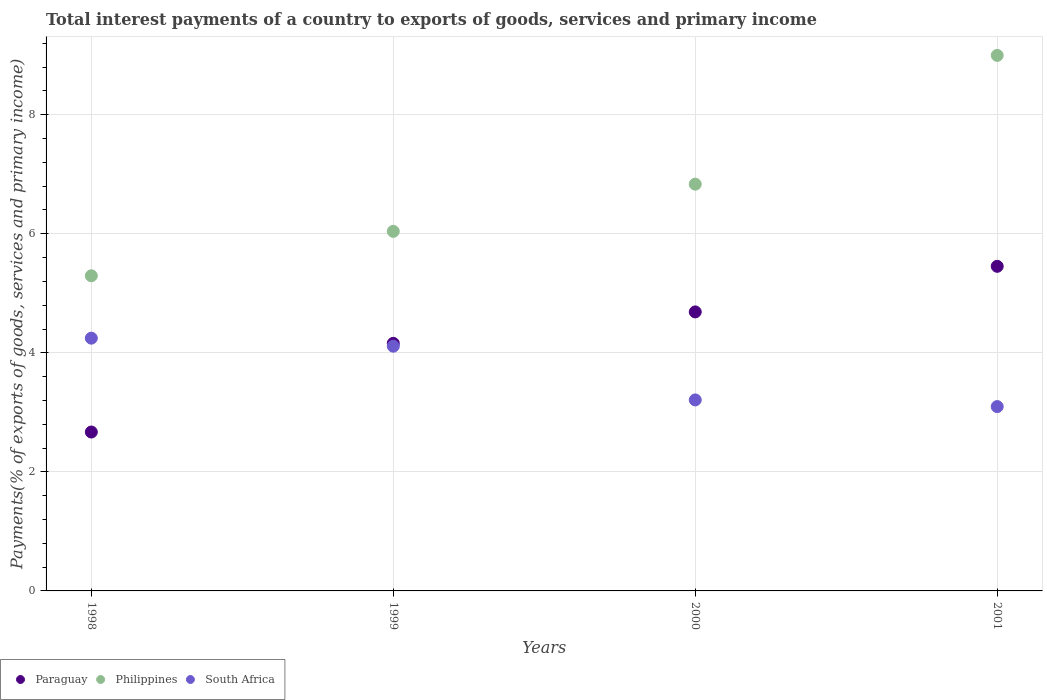How many different coloured dotlines are there?
Your response must be concise. 3. Is the number of dotlines equal to the number of legend labels?
Your answer should be very brief. Yes. What is the total interest payments in Paraguay in 1999?
Your answer should be very brief. 4.16. Across all years, what is the maximum total interest payments in Paraguay?
Offer a terse response. 5.45. Across all years, what is the minimum total interest payments in Philippines?
Provide a short and direct response. 5.29. What is the total total interest payments in South Africa in the graph?
Provide a succinct answer. 14.66. What is the difference between the total interest payments in Paraguay in 1999 and that in 2000?
Offer a terse response. -0.53. What is the difference between the total interest payments in South Africa in 1998 and the total interest payments in Philippines in 2000?
Your response must be concise. -2.59. What is the average total interest payments in Philippines per year?
Provide a succinct answer. 6.79. In the year 1999, what is the difference between the total interest payments in Paraguay and total interest payments in South Africa?
Ensure brevity in your answer.  0.05. What is the ratio of the total interest payments in Paraguay in 1998 to that in 1999?
Offer a terse response. 0.64. What is the difference between the highest and the second highest total interest payments in Philippines?
Offer a very short reply. 2.16. What is the difference between the highest and the lowest total interest payments in Philippines?
Give a very brief answer. 3.7. Is the total interest payments in Paraguay strictly greater than the total interest payments in South Africa over the years?
Offer a very short reply. No. How are the legend labels stacked?
Your response must be concise. Horizontal. What is the title of the graph?
Keep it short and to the point. Total interest payments of a country to exports of goods, services and primary income. What is the label or title of the Y-axis?
Offer a terse response. Payments(% of exports of goods, services and primary income). What is the Payments(% of exports of goods, services and primary income) of Paraguay in 1998?
Offer a very short reply. 2.67. What is the Payments(% of exports of goods, services and primary income) in Philippines in 1998?
Your response must be concise. 5.29. What is the Payments(% of exports of goods, services and primary income) in South Africa in 1998?
Provide a succinct answer. 4.25. What is the Payments(% of exports of goods, services and primary income) in Paraguay in 1999?
Your answer should be very brief. 4.16. What is the Payments(% of exports of goods, services and primary income) in Philippines in 1999?
Your answer should be compact. 6.04. What is the Payments(% of exports of goods, services and primary income) of South Africa in 1999?
Make the answer very short. 4.11. What is the Payments(% of exports of goods, services and primary income) of Paraguay in 2000?
Make the answer very short. 4.69. What is the Payments(% of exports of goods, services and primary income) of Philippines in 2000?
Provide a short and direct response. 6.83. What is the Payments(% of exports of goods, services and primary income) in South Africa in 2000?
Provide a succinct answer. 3.21. What is the Payments(% of exports of goods, services and primary income) of Paraguay in 2001?
Offer a very short reply. 5.45. What is the Payments(% of exports of goods, services and primary income) of Philippines in 2001?
Your response must be concise. 9. What is the Payments(% of exports of goods, services and primary income) of South Africa in 2001?
Keep it short and to the point. 3.1. Across all years, what is the maximum Payments(% of exports of goods, services and primary income) in Paraguay?
Provide a short and direct response. 5.45. Across all years, what is the maximum Payments(% of exports of goods, services and primary income) of Philippines?
Make the answer very short. 9. Across all years, what is the maximum Payments(% of exports of goods, services and primary income) of South Africa?
Provide a short and direct response. 4.25. Across all years, what is the minimum Payments(% of exports of goods, services and primary income) in Paraguay?
Offer a terse response. 2.67. Across all years, what is the minimum Payments(% of exports of goods, services and primary income) in Philippines?
Your answer should be compact. 5.29. Across all years, what is the minimum Payments(% of exports of goods, services and primary income) in South Africa?
Give a very brief answer. 3.1. What is the total Payments(% of exports of goods, services and primary income) of Paraguay in the graph?
Your answer should be compact. 16.97. What is the total Payments(% of exports of goods, services and primary income) of Philippines in the graph?
Your answer should be very brief. 27.16. What is the total Payments(% of exports of goods, services and primary income) in South Africa in the graph?
Provide a succinct answer. 14.66. What is the difference between the Payments(% of exports of goods, services and primary income) of Paraguay in 1998 and that in 1999?
Keep it short and to the point. -1.49. What is the difference between the Payments(% of exports of goods, services and primary income) of Philippines in 1998 and that in 1999?
Provide a succinct answer. -0.75. What is the difference between the Payments(% of exports of goods, services and primary income) of South Africa in 1998 and that in 1999?
Keep it short and to the point. 0.14. What is the difference between the Payments(% of exports of goods, services and primary income) in Paraguay in 1998 and that in 2000?
Offer a terse response. -2.02. What is the difference between the Payments(% of exports of goods, services and primary income) in Philippines in 1998 and that in 2000?
Make the answer very short. -1.54. What is the difference between the Payments(% of exports of goods, services and primary income) of South Africa in 1998 and that in 2000?
Your answer should be compact. 1.04. What is the difference between the Payments(% of exports of goods, services and primary income) of Paraguay in 1998 and that in 2001?
Your response must be concise. -2.78. What is the difference between the Payments(% of exports of goods, services and primary income) in Philippines in 1998 and that in 2001?
Make the answer very short. -3.7. What is the difference between the Payments(% of exports of goods, services and primary income) in South Africa in 1998 and that in 2001?
Offer a very short reply. 1.15. What is the difference between the Payments(% of exports of goods, services and primary income) of Paraguay in 1999 and that in 2000?
Offer a terse response. -0.53. What is the difference between the Payments(% of exports of goods, services and primary income) of Philippines in 1999 and that in 2000?
Give a very brief answer. -0.79. What is the difference between the Payments(% of exports of goods, services and primary income) of South Africa in 1999 and that in 2000?
Your answer should be compact. 0.9. What is the difference between the Payments(% of exports of goods, services and primary income) in Paraguay in 1999 and that in 2001?
Provide a short and direct response. -1.29. What is the difference between the Payments(% of exports of goods, services and primary income) in Philippines in 1999 and that in 2001?
Your response must be concise. -2.96. What is the difference between the Payments(% of exports of goods, services and primary income) of South Africa in 1999 and that in 2001?
Offer a very short reply. 1.01. What is the difference between the Payments(% of exports of goods, services and primary income) of Paraguay in 2000 and that in 2001?
Provide a short and direct response. -0.77. What is the difference between the Payments(% of exports of goods, services and primary income) of Philippines in 2000 and that in 2001?
Provide a short and direct response. -2.16. What is the difference between the Payments(% of exports of goods, services and primary income) of South Africa in 2000 and that in 2001?
Provide a succinct answer. 0.11. What is the difference between the Payments(% of exports of goods, services and primary income) of Paraguay in 1998 and the Payments(% of exports of goods, services and primary income) of Philippines in 1999?
Offer a very short reply. -3.37. What is the difference between the Payments(% of exports of goods, services and primary income) of Paraguay in 1998 and the Payments(% of exports of goods, services and primary income) of South Africa in 1999?
Keep it short and to the point. -1.44. What is the difference between the Payments(% of exports of goods, services and primary income) in Philippines in 1998 and the Payments(% of exports of goods, services and primary income) in South Africa in 1999?
Offer a terse response. 1.18. What is the difference between the Payments(% of exports of goods, services and primary income) of Paraguay in 1998 and the Payments(% of exports of goods, services and primary income) of Philippines in 2000?
Offer a terse response. -4.16. What is the difference between the Payments(% of exports of goods, services and primary income) of Paraguay in 1998 and the Payments(% of exports of goods, services and primary income) of South Africa in 2000?
Offer a very short reply. -0.54. What is the difference between the Payments(% of exports of goods, services and primary income) of Philippines in 1998 and the Payments(% of exports of goods, services and primary income) of South Africa in 2000?
Provide a short and direct response. 2.09. What is the difference between the Payments(% of exports of goods, services and primary income) of Paraguay in 1998 and the Payments(% of exports of goods, services and primary income) of Philippines in 2001?
Keep it short and to the point. -6.33. What is the difference between the Payments(% of exports of goods, services and primary income) in Paraguay in 1998 and the Payments(% of exports of goods, services and primary income) in South Africa in 2001?
Keep it short and to the point. -0.43. What is the difference between the Payments(% of exports of goods, services and primary income) in Philippines in 1998 and the Payments(% of exports of goods, services and primary income) in South Africa in 2001?
Your response must be concise. 2.2. What is the difference between the Payments(% of exports of goods, services and primary income) of Paraguay in 1999 and the Payments(% of exports of goods, services and primary income) of Philippines in 2000?
Keep it short and to the point. -2.67. What is the difference between the Payments(% of exports of goods, services and primary income) of Paraguay in 1999 and the Payments(% of exports of goods, services and primary income) of South Africa in 2000?
Offer a very short reply. 0.95. What is the difference between the Payments(% of exports of goods, services and primary income) of Philippines in 1999 and the Payments(% of exports of goods, services and primary income) of South Africa in 2000?
Offer a very short reply. 2.83. What is the difference between the Payments(% of exports of goods, services and primary income) of Paraguay in 1999 and the Payments(% of exports of goods, services and primary income) of Philippines in 2001?
Offer a terse response. -4.84. What is the difference between the Payments(% of exports of goods, services and primary income) of Paraguay in 1999 and the Payments(% of exports of goods, services and primary income) of South Africa in 2001?
Ensure brevity in your answer.  1.06. What is the difference between the Payments(% of exports of goods, services and primary income) in Philippines in 1999 and the Payments(% of exports of goods, services and primary income) in South Africa in 2001?
Make the answer very short. 2.94. What is the difference between the Payments(% of exports of goods, services and primary income) in Paraguay in 2000 and the Payments(% of exports of goods, services and primary income) in Philippines in 2001?
Your answer should be very brief. -4.31. What is the difference between the Payments(% of exports of goods, services and primary income) in Paraguay in 2000 and the Payments(% of exports of goods, services and primary income) in South Africa in 2001?
Offer a very short reply. 1.59. What is the difference between the Payments(% of exports of goods, services and primary income) in Philippines in 2000 and the Payments(% of exports of goods, services and primary income) in South Africa in 2001?
Your answer should be very brief. 3.74. What is the average Payments(% of exports of goods, services and primary income) in Paraguay per year?
Your response must be concise. 4.24. What is the average Payments(% of exports of goods, services and primary income) of Philippines per year?
Your response must be concise. 6.79. What is the average Payments(% of exports of goods, services and primary income) in South Africa per year?
Ensure brevity in your answer.  3.67. In the year 1998, what is the difference between the Payments(% of exports of goods, services and primary income) of Paraguay and Payments(% of exports of goods, services and primary income) of Philippines?
Provide a short and direct response. -2.62. In the year 1998, what is the difference between the Payments(% of exports of goods, services and primary income) in Paraguay and Payments(% of exports of goods, services and primary income) in South Africa?
Give a very brief answer. -1.58. In the year 1998, what is the difference between the Payments(% of exports of goods, services and primary income) of Philippines and Payments(% of exports of goods, services and primary income) of South Africa?
Ensure brevity in your answer.  1.05. In the year 1999, what is the difference between the Payments(% of exports of goods, services and primary income) of Paraguay and Payments(% of exports of goods, services and primary income) of Philippines?
Provide a succinct answer. -1.88. In the year 1999, what is the difference between the Payments(% of exports of goods, services and primary income) in Paraguay and Payments(% of exports of goods, services and primary income) in South Africa?
Provide a succinct answer. 0.05. In the year 1999, what is the difference between the Payments(% of exports of goods, services and primary income) in Philippines and Payments(% of exports of goods, services and primary income) in South Africa?
Your answer should be compact. 1.93. In the year 2000, what is the difference between the Payments(% of exports of goods, services and primary income) of Paraguay and Payments(% of exports of goods, services and primary income) of Philippines?
Offer a very short reply. -2.15. In the year 2000, what is the difference between the Payments(% of exports of goods, services and primary income) in Paraguay and Payments(% of exports of goods, services and primary income) in South Africa?
Offer a very short reply. 1.48. In the year 2000, what is the difference between the Payments(% of exports of goods, services and primary income) in Philippines and Payments(% of exports of goods, services and primary income) in South Africa?
Your response must be concise. 3.62. In the year 2001, what is the difference between the Payments(% of exports of goods, services and primary income) in Paraguay and Payments(% of exports of goods, services and primary income) in Philippines?
Provide a succinct answer. -3.54. In the year 2001, what is the difference between the Payments(% of exports of goods, services and primary income) in Paraguay and Payments(% of exports of goods, services and primary income) in South Africa?
Your answer should be very brief. 2.36. In the year 2001, what is the difference between the Payments(% of exports of goods, services and primary income) of Philippines and Payments(% of exports of goods, services and primary income) of South Africa?
Offer a very short reply. 5.9. What is the ratio of the Payments(% of exports of goods, services and primary income) in Paraguay in 1998 to that in 1999?
Your answer should be compact. 0.64. What is the ratio of the Payments(% of exports of goods, services and primary income) of Philippines in 1998 to that in 1999?
Provide a short and direct response. 0.88. What is the ratio of the Payments(% of exports of goods, services and primary income) of South Africa in 1998 to that in 1999?
Your response must be concise. 1.03. What is the ratio of the Payments(% of exports of goods, services and primary income) in Paraguay in 1998 to that in 2000?
Your response must be concise. 0.57. What is the ratio of the Payments(% of exports of goods, services and primary income) of Philippines in 1998 to that in 2000?
Your response must be concise. 0.77. What is the ratio of the Payments(% of exports of goods, services and primary income) in South Africa in 1998 to that in 2000?
Ensure brevity in your answer.  1.32. What is the ratio of the Payments(% of exports of goods, services and primary income) in Paraguay in 1998 to that in 2001?
Provide a short and direct response. 0.49. What is the ratio of the Payments(% of exports of goods, services and primary income) in Philippines in 1998 to that in 2001?
Offer a very short reply. 0.59. What is the ratio of the Payments(% of exports of goods, services and primary income) in South Africa in 1998 to that in 2001?
Your answer should be very brief. 1.37. What is the ratio of the Payments(% of exports of goods, services and primary income) of Paraguay in 1999 to that in 2000?
Give a very brief answer. 0.89. What is the ratio of the Payments(% of exports of goods, services and primary income) in Philippines in 1999 to that in 2000?
Provide a succinct answer. 0.88. What is the ratio of the Payments(% of exports of goods, services and primary income) of South Africa in 1999 to that in 2000?
Give a very brief answer. 1.28. What is the ratio of the Payments(% of exports of goods, services and primary income) of Paraguay in 1999 to that in 2001?
Give a very brief answer. 0.76. What is the ratio of the Payments(% of exports of goods, services and primary income) in Philippines in 1999 to that in 2001?
Your answer should be very brief. 0.67. What is the ratio of the Payments(% of exports of goods, services and primary income) of South Africa in 1999 to that in 2001?
Your answer should be compact. 1.33. What is the ratio of the Payments(% of exports of goods, services and primary income) in Paraguay in 2000 to that in 2001?
Give a very brief answer. 0.86. What is the ratio of the Payments(% of exports of goods, services and primary income) of Philippines in 2000 to that in 2001?
Offer a very short reply. 0.76. What is the ratio of the Payments(% of exports of goods, services and primary income) of South Africa in 2000 to that in 2001?
Your answer should be compact. 1.04. What is the difference between the highest and the second highest Payments(% of exports of goods, services and primary income) of Paraguay?
Your answer should be compact. 0.77. What is the difference between the highest and the second highest Payments(% of exports of goods, services and primary income) of Philippines?
Your response must be concise. 2.16. What is the difference between the highest and the second highest Payments(% of exports of goods, services and primary income) of South Africa?
Offer a very short reply. 0.14. What is the difference between the highest and the lowest Payments(% of exports of goods, services and primary income) of Paraguay?
Offer a very short reply. 2.78. What is the difference between the highest and the lowest Payments(% of exports of goods, services and primary income) in Philippines?
Your answer should be very brief. 3.7. What is the difference between the highest and the lowest Payments(% of exports of goods, services and primary income) in South Africa?
Give a very brief answer. 1.15. 